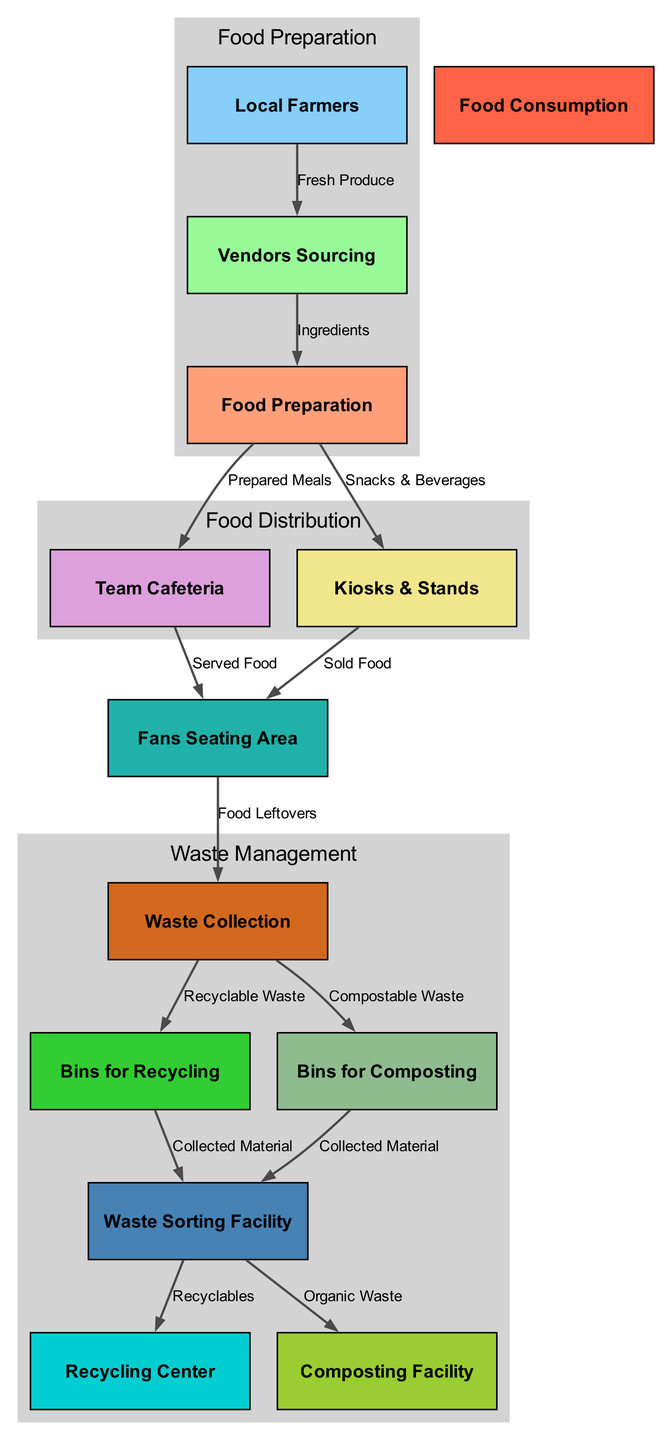What are the nodes involved in food preparation? The nodes related to food preparation are 'food_preparation', 'vendors_sourcing', and 'local_farmers'. These nodes directly connect in the food supply process, starting from local farmers providing fresh produce to vendors who source the ingredients, which are then prepared as meals.
Answer: food preparation, vendors sourcing, local farmers How many nodes are in the waste management section? The waste management section includes the nodes 'waste_collection', 'bins_recycling', 'bins_composting', 'sorting_facility', 'recycling_center', and 'composting_facility'. Counting these nodes gives a total of six.
Answer: 6 What type of waste is collected from the fans' seating area? From the fans' seating area, 'Food Leftovers' are the type of waste that is collected, which enters the waste collection phase.
Answer: Food Leftovers What is the relationship between waste collection and recycling? 'Waste Collection' leads to 'Bins for Recycling' indicating that recyclable waste is sorted into specific bins after collection. This shows a direct flow from waste collection to recycling bins.
Answer: Bins for Recycling What happens to the compostable waste? The compostable waste is directed to 'Bins for Composting', which signifies that it is collected separately, ready for processing into compost. The relationship is established right after waste collection.
Answer: Bins for Composting How many edges connect local farmers to vendors sourcing? There is one edge connecting 'local_farmers' to 'vendors_sourcing', labeled 'Fresh Produce'. This indicates a direct connection in the supply chain process where farmers provide produce to vendors.
Answer: 1 Which facility processes recyclables after sorting? After the sorting facility processes recyclables, they are directed to the 'Recycling Center' for further processing. This relationship indicates the final stage of recycling waste management.
Answer: Recycling Center What types of food are served to fans at the seating area from kiosks and stands? Fans receive 'Sold Food' from the 'Kiosks & Stands' node, which points to the engagement of fans in consuming food sold by these vendors.
Answer: Sold Food What does the sorting facility do with the collected materials? The sorting facility separates the collected materials into different categories: 'Recyclables' are sent to the 'Recycling Center', and 'Organic Waste' goes to the 'Composting Facility'. This explains the processing of collected materials.
Answer: Recycling Center, Composting Facility 